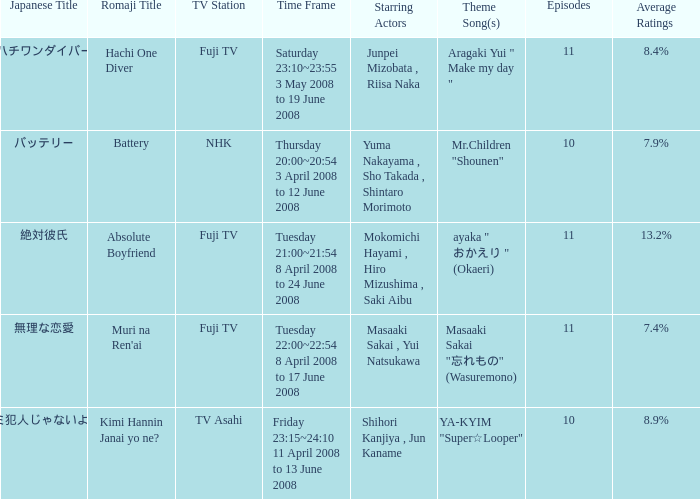What is the average rating for tv asahi? 8.9%. 